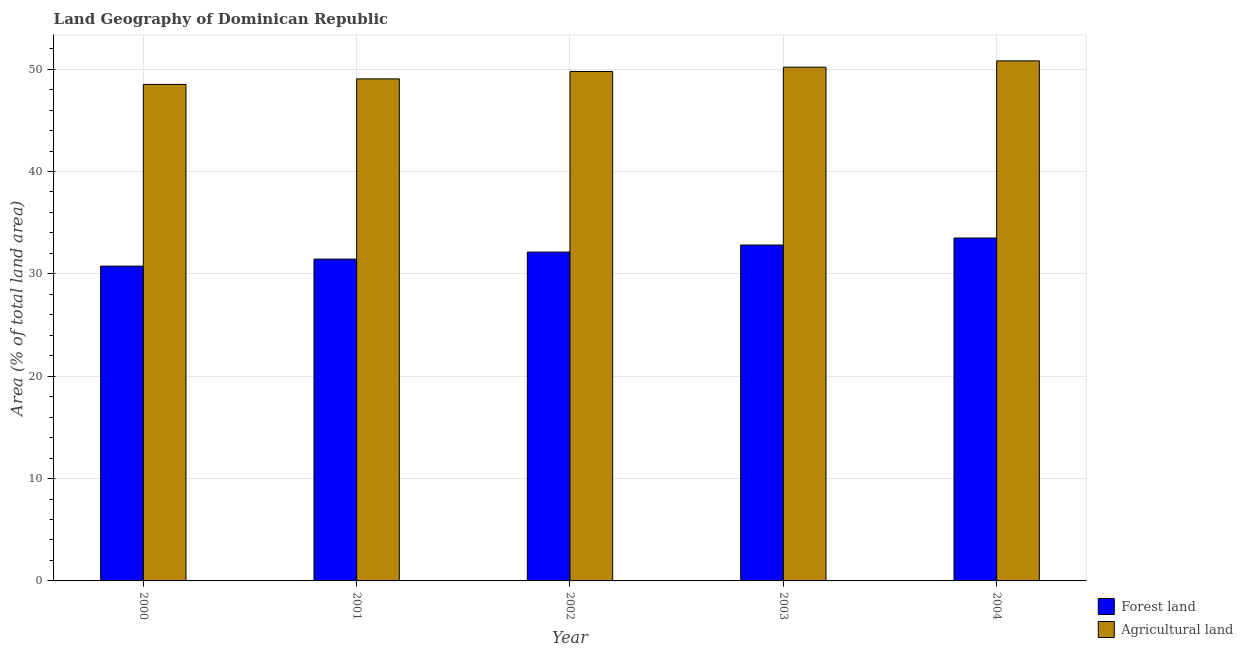How many different coloured bars are there?
Provide a succinct answer. 2. How many groups of bars are there?
Offer a very short reply. 5. Are the number of bars on each tick of the X-axis equal?
Make the answer very short. Yes. How many bars are there on the 2nd tick from the right?
Your answer should be very brief. 2. What is the percentage of land area under forests in 2002?
Offer a terse response. 32.13. Across all years, what is the maximum percentage of land area under forests?
Your answer should be very brief. 33.5. Across all years, what is the minimum percentage of land area under forests?
Offer a terse response. 30.75. In which year was the percentage of land area under forests maximum?
Your answer should be compact. 2004. What is the total percentage of land area under agriculture in the graph?
Your answer should be compact. 248.32. What is the difference between the percentage of land area under forests in 2001 and that in 2004?
Provide a short and direct response. -2.06. What is the difference between the percentage of land area under agriculture in 2002 and the percentage of land area under forests in 2000?
Offer a very short reply. 1.26. What is the average percentage of land area under agriculture per year?
Give a very brief answer. 49.66. In how many years, is the percentage of land area under forests greater than 4 %?
Keep it short and to the point. 5. What is the ratio of the percentage of land area under forests in 2001 to that in 2002?
Keep it short and to the point. 0.98. Is the difference between the percentage of land area under forests in 2000 and 2003 greater than the difference between the percentage of land area under agriculture in 2000 and 2003?
Keep it short and to the point. No. What is the difference between the highest and the second highest percentage of land area under agriculture?
Offer a very short reply. 0.62. What is the difference between the highest and the lowest percentage of land area under forests?
Your answer should be very brief. 2.75. In how many years, is the percentage of land area under forests greater than the average percentage of land area under forests taken over all years?
Provide a succinct answer. 2. What does the 2nd bar from the left in 2004 represents?
Offer a very short reply. Agricultural land. What does the 2nd bar from the right in 2003 represents?
Offer a terse response. Forest land. How many bars are there?
Offer a very short reply. 10. Does the graph contain grids?
Provide a succinct answer. Yes. Where does the legend appear in the graph?
Your answer should be very brief. Bottom right. How are the legend labels stacked?
Provide a short and direct response. Vertical. What is the title of the graph?
Your answer should be compact. Land Geography of Dominican Republic. Does "Working only" appear as one of the legend labels in the graph?
Provide a short and direct response. No. What is the label or title of the Y-axis?
Your answer should be compact. Area (% of total land area). What is the Area (% of total land area) of Forest land in 2000?
Your answer should be very brief. 30.75. What is the Area (% of total land area) in Agricultural land in 2000?
Provide a short and direct response. 48.51. What is the Area (% of total land area) of Forest land in 2001?
Provide a short and direct response. 31.44. What is the Area (% of total land area) of Agricultural land in 2001?
Keep it short and to the point. 49.05. What is the Area (% of total land area) in Forest land in 2002?
Give a very brief answer. 32.13. What is the Area (% of total land area) of Agricultural land in 2002?
Provide a short and direct response. 49.77. What is the Area (% of total land area) in Forest land in 2003?
Provide a short and direct response. 32.81. What is the Area (% of total land area) of Agricultural land in 2003?
Ensure brevity in your answer.  50.19. What is the Area (% of total land area) of Forest land in 2004?
Make the answer very short. 33.5. What is the Area (% of total land area) in Agricultural land in 2004?
Offer a terse response. 50.81. Across all years, what is the maximum Area (% of total land area) of Forest land?
Provide a short and direct response. 33.5. Across all years, what is the maximum Area (% of total land area) of Agricultural land?
Offer a very short reply. 50.81. Across all years, what is the minimum Area (% of total land area) of Forest land?
Keep it short and to the point. 30.75. Across all years, what is the minimum Area (% of total land area) of Agricultural land?
Provide a succinct answer. 48.51. What is the total Area (% of total land area) in Forest land in the graph?
Your answer should be very brief. 160.64. What is the total Area (% of total land area) in Agricultural land in the graph?
Keep it short and to the point. 248.32. What is the difference between the Area (% of total land area) in Forest land in 2000 and that in 2001?
Keep it short and to the point. -0.69. What is the difference between the Area (% of total land area) of Agricultural land in 2000 and that in 2001?
Provide a succinct answer. -0.54. What is the difference between the Area (% of total land area) of Forest land in 2000 and that in 2002?
Offer a terse response. -1.37. What is the difference between the Area (% of total land area) in Agricultural land in 2000 and that in 2002?
Offer a very short reply. -1.26. What is the difference between the Area (% of total land area) of Forest land in 2000 and that in 2003?
Ensure brevity in your answer.  -2.06. What is the difference between the Area (% of total land area) in Agricultural land in 2000 and that in 2003?
Your answer should be very brief. -1.68. What is the difference between the Area (% of total land area) in Forest land in 2000 and that in 2004?
Your response must be concise. -2.75. What is the difference between the Area (% of total land area) of Agricultural land in 2000 and that in 2004?
Provide a short and direct response. -2.3. What is the difference between the Area (% of total land area) of Forest land in 2001 and that in 2002?
Ensure brevity in your answer.  -0.69. What is the difference between the Area (% of total land area) in Agricultural land in 2001 and that in 2002?
Offer a terse response. -0.72. What is the difference between the Area (% of total land area) of Forest land in 2001 and that in 2003?
Ensure brevity in your answer.  -1.37. What is the difference between the Area (% of total land area) in Agricultural land in 2001 and that in 2003?
Give a very brief answer. -1.14. What is the difference between the Area (% of total land area) in Forest land in 2001 and that in 2004?
Your response must be concise. -2.06. What is the difference between the Area (% of total land area) in Agricultural land in 2001 and that in 2004?
Ensure brevity in your answer.  -1.76. What is the difference between the Area (% of total land area) of Forest land in 2002 and that in 2003?
Offer a very short reply. -0.69. What is the difference between the Area (% of total land area) in Agricultural land in 2002 and that in 2003?
Your answer should be very brief. -0.41. What is the difference between the Area (% of total land area) of Forest land in 2002 and that in 2004?
Give a very brief answer. -1.37. What is the difference between the Area (% of total land area) of Agricultural land in 2002 and that in 2004?
Give a very brief answer. -1.03. What is the difference between the Area (% of total land area) of Forest land in 2003 and that in 2004?
Your answer should be compact. -0.69. What is the difference between the Area (% of total land area) of Agricultural land in 2003 and that in 2004?
Provide a succinct answer. -0.62. What is the difference between the Area (% of total land area) in Forest land in 2000 and the Area (% of total land area) in Agricultural land in 2001?
Your answer should be compact. -18.29. What is the difference between the Area (% of total land area) of Forest land in 2000 and the Area (% of total land area) of Agricultural land in 2002?
Ensure brevity in your answer.  -19.02. What is the difference between the Area (% of total land area) in Forest land in 2000 and the Area (% of total land area) in Agricultural land in 2003?
Provide a short and direct response. -19.43. What is the difference between the Area (% of total land area) of Forest land in 2000 and the Area (% of total land area) of Agricultural land in 2004?
Provide a succinct answer. -20.05. What is the difference between the Area (% of total land area) of Forest land in 2001 and the Area (% of total land area) of Agricultural land in 2002?
Keep it short and to the point. -18.33. What is the difference between the Area (% of total land area) in Forest land in 2001 and the Area (% of total land area) in Agricultural land in 2003?
Ensure brevity in your answer.  -18.75. What is the difference between the Area (% of total land area) in Forest land in 2001 and the Area (% of total land area) in Agricultural land in 2004?
Give a very brief answer. -19.37. What is the difference between the Area (% of total land area) of Forest land in 2002 and the Area (% of total land area) of Agricultural land in 2003?
Your answer should be compact. -18.06. What is the difference between the Area (% of total land area) of Forest land in 2002 and the Area (% of total land area) of Agricultural land in 2004?
Your answer should be very brief. -18.68. What is the difference between the Area (% of total land area) of Forest land in 2003 and the Area (% of total land area) of Agricultural land in 2004?
Your response must be concise. -17.99. What is the average Area (% of total land area) of Forest land per year?
Ensure brevity in your answer.  32.13. What is the average Area (% of total land area) of Agricultural land per year?
Keep it short and to the point. 49.66. In the year 2000, what is the difference between the Area (% of total land area) in Forest land and Area (% of total land area) in Agricultural land?
Make the answer very short. -17.76. In the year 2001, what is the difference between the Area (% of total land area) in Forest land and Area (% of total land area) in Agricultural land?
Your answer should be very brief. -17.61. In the year 2002, what is the difference between the Area (% of total land area) in Forest land and Area (% of total land area) in Agricultural land?
Keep it short and to the point. -17.64. In the year 2003, what is the difference between the Area (% of total land area) in Forest land and Area (% of total land area) in Agricultural land?
Offer a very short reply. -17.37. In the year 2004, what is the difference between the Area (% of total land area) in Forest land and Area (% of total land area) in Agricultural land?
Provide a short and direct response. -17.31. What is the ratio of the Area (% of total land area) of Forest land in 2000 to that in 2001?
Your answer should be very brief. 0.98. What is the ratio of the Area (% of total land area) of Forest land in 2000 to that in 2002?
Offer a terse response. 0.96. What is the ratio of the Area (% of total land area) in Agricultural land in 2000 to that in 2002?
Provide a succinct answer. 0.97. What is the ratio of the Area (% of total land area) of Forest land in 2000 to that in 2003?
Give a very brief answer. 0.94. What is the ratio of the Area (% of total land area) of Agricultural land in 2000 to that in 2003?
Keep it short and to the point. 0.97. What is the ratio of the Area (% of total land area) in Forest land in 2000 to that in 2004?
Your answer should be compact. 0.92. What is the ratio of the Area (% of total land area) of Agricultural land in 2000 to that in 2004?
Your answer should be very brief. 0.95. What is the ratio of the Area (% of total land area) of Forest land in 2001 to that in 2002?
Keep it short and to the point. 0.98. What is the ratio of the Area (% of total land area) in Agricultural land in 2001 to that in 2002?
Offer a terse response. 0.99. What is the ratio of the Area (% of total land area) in Forest land in 2001 to that in 2003?
Your response must be concise. 0.96. What is the ratio of the Area (% of total land area) in Agricultural land in 2001 to that in 2003?
Offer a very short reply. 0.98. What is the ratio of the Area (% of total land area) in Forest land in 2001 to that in 2004?
Give a very brief answer. 0.94. What is the ratio of the Area (% of total land area) in Agricultural land in 2001 to that in 2004?
Provide a short and direct response. 0.97. What is the ratio of the Area (% of total land area) in Forest land in 2002 to that in 2003?
Ensure brevity in your answer.  0.98. What is the ratio of the Area (% of total land area) in Agricultural land in 2002 to that in 2003?
Give a very brief answer. 0.99. What is the ratio of the Area (% of total land area) of Agricultural land in 2002 to that in 2004?
Your response must be concise. 0.98. What is the ratio of the Area (% of total land area) of Forest land in 2003 to that in 2004?
Offer a very short reply. 0.98. What is the difference between the highest and the second highest Area (% of total land area) in Forest land?
Give a very brief answer. 0.69. What is the difference between the highest and the second highest Area (% of total land area) in Agricultural land?
Provide a short and direct response. 0.62. What is the difference between the highest and the lowest Area (% of total land area) in Forest land?
Provide a succinct answer. 2.75. What is the difference between the highest and the lowest Area (% of total land area) in Agricultural land?
Make the answer very short. 2.3. 